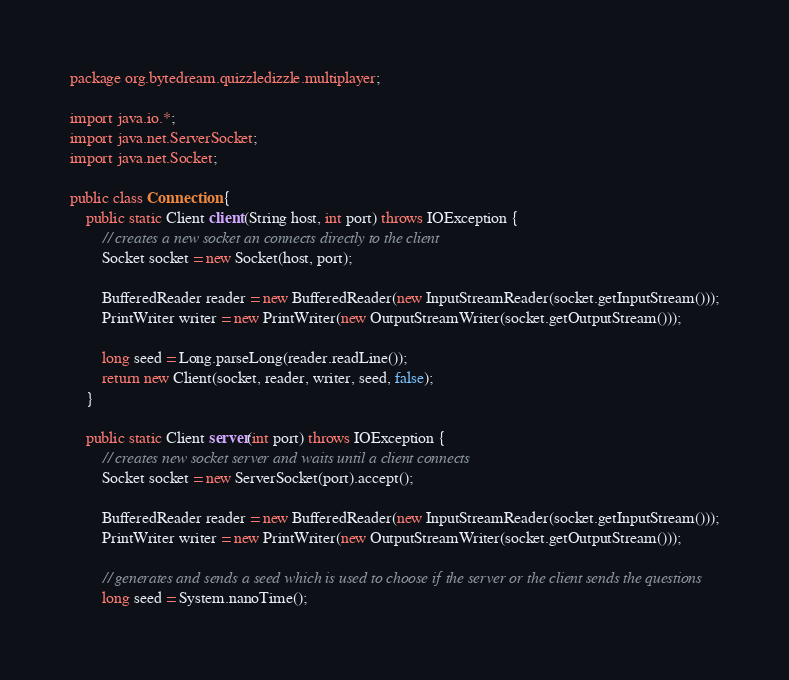Convert code to text. <code><loc_0><loc_0><loc_500><loc_500><_Java_>package org.bytedream.quizzledizzle.multiplayer;

import java.io.*;
import java.net.ServerSocket;
import java.net.Socket;

public class Connection {
    public static Client client(String host, int port) throws IOException {
        // creates a new socket an connects directly to the client
        Socket socket = new Socket(host, port);

        BufferedReader reader = new BufferedReader(new InputStreamReader(socket.getInputStream()));
        PrintWriter writer = new PrintWriter(new OutputStreamWriter(socket.getOutputStream()));

        long seed = Long.parseLong(reader.readLine());
        return new Client(socket, reader, writer, seed, false);
    }

    public static Client server(int port) throws IOException {
        // creates new socket server and waits until a client connects
        Socket socket = new ServerSocket(port).accept();

        BufferedReader reader = new BufferedReader(new InputStreamReader(socket.getInputStream()));
        PrintWriter writer = new PrintWriter(new OutputStreamWriter(socket.getOutputStream()));

        // generates and sends a seed which is used to choose if the server or the client sends the questions
        long seed = System.nanoTime();</code> 